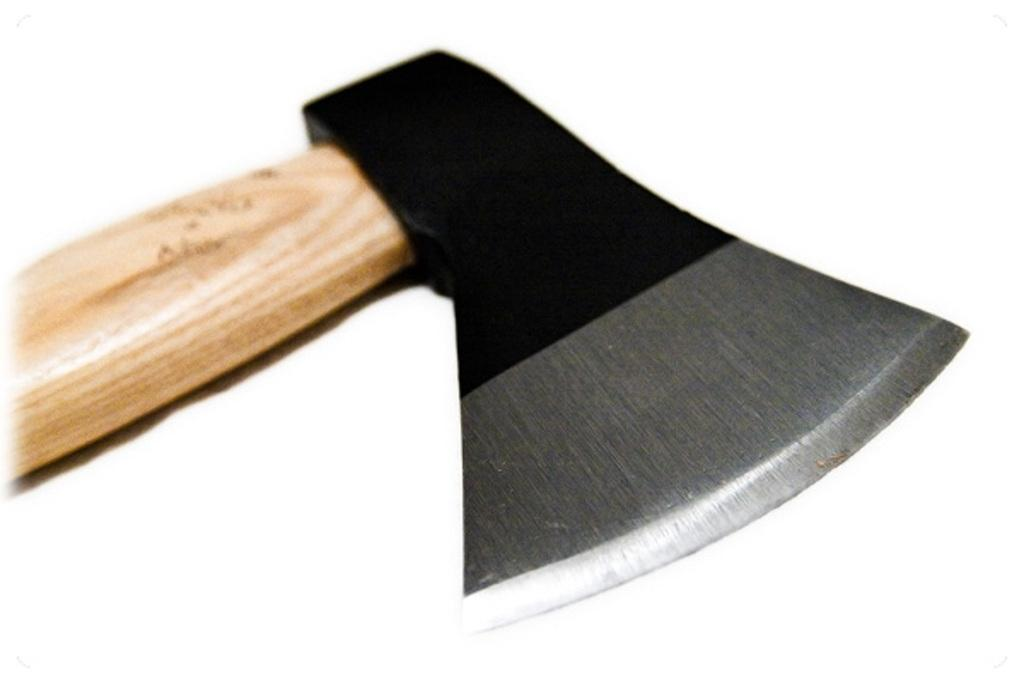What object is located in the center of the image? There is an axe present in the image, and it is located in the center. How many planes are flying in the background of the image? There are no planes visible in the image; it only features an axe in the center. What type of jelly is being used to sharpen the axe in the image? There is no jelly present in the image, and the axe does not appear to be in use or being sharpened. 